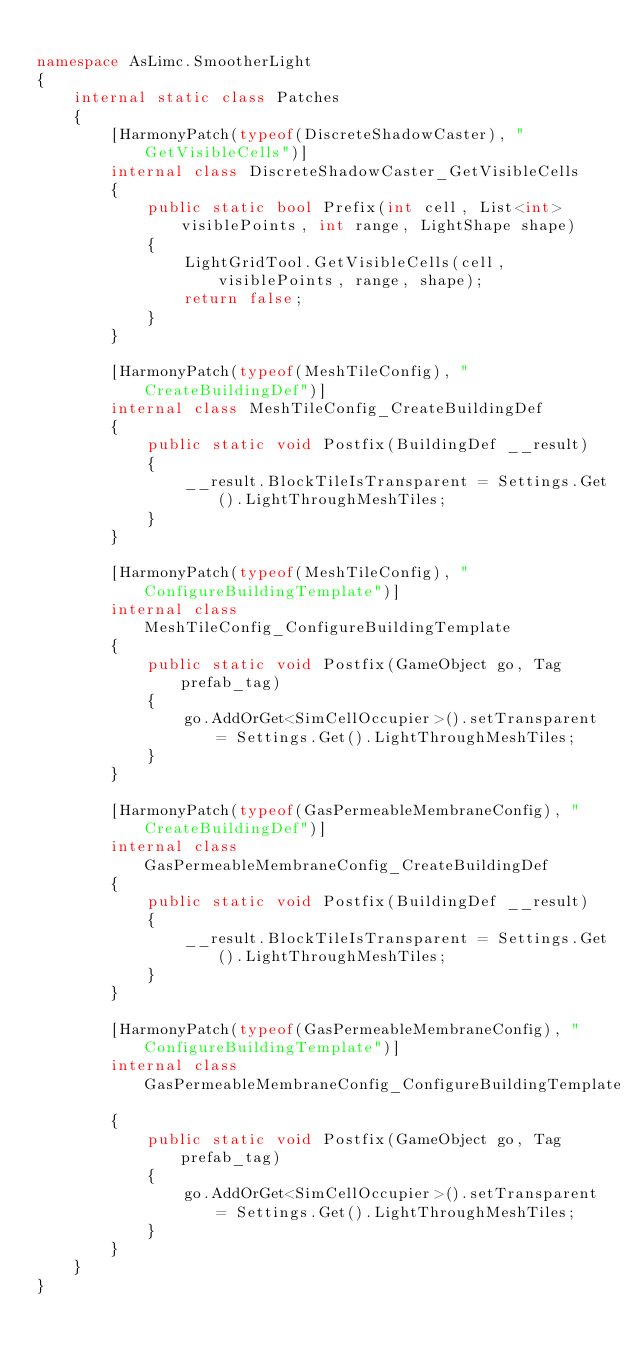<code> <loc_0><loc_0><loc_500><loc_500><_C#_>
namespace AsLimc.SmootherLight
{
    internal static class Patches
    {
        [HarmonyPatch(typeof(DiscreteShadowCaster), "GetVisibleCells")]
        internal class DiscreteShadowCaster_GetVisibleCells
        {
            public static bool Prefix(int cell, List<int> visiblePoints, int range, LightShape shape)
            {
                LightGridTool.GetVisibleCells(cell, visiblePoints, range, shape);
                return false;
            }
        }

        [HarmonyPatch(typeof(MeshTileConfig), "CreateBuildingDef")]
        internal class MeshTileConfig_CreateBuildingDef
        {
            public static void Postfix(BuildingDef __result)
            {
                __result.BlockTileIsTransparent = Settings.Get().LightThroughMeshTiles;
            }
        }

        [HarmonyPatch(typeof(MeshTileConfig), "ConfigureBuildingTemplate")]
        internal class MeshTileConfig_ConfigureBuildingTemplate
        {
            public static void Postfix(GameObject go, Tag prefab_tag)
            {
                go.AddOrGet<SimCellOccupier>().setTransparent = Settings.Get().LightThroughMeshTiles;
            }
        }

        [HarmonyPatch(typeof(GasPermeableMembraneConfig), "CreateBuildingDef")]
        internal class GasPermeableMembraneConfig_CreateBuildingDef
        {
            public static void Postfix(BuildingDef __result)
            {
                __result.BlockTileIsTransparent = Settings.Get().LightThroughMeshTiles;
            }
        }

        [HarmonyPatch(typeof(GasPermeableMembraneConfig), "ConfigureBuildingTemplate")]
        internal class GasPermeableMembraneConfig_ConfigureBuildingTemplate
        {
            public static void Postfix(GameObject go, Tag prefab_tag)
            {
                go.AddOrGet<SimCellOccupier>().setTransparent = Settings.Get().LightThroughMeshTiles;
            }
        }
    }
}</code> 